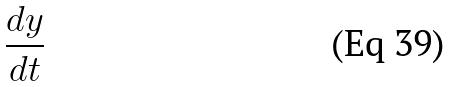<formula> <loc_0><loc_0><loc_500><loc_500>\frac { d y } { d t }</formula> 